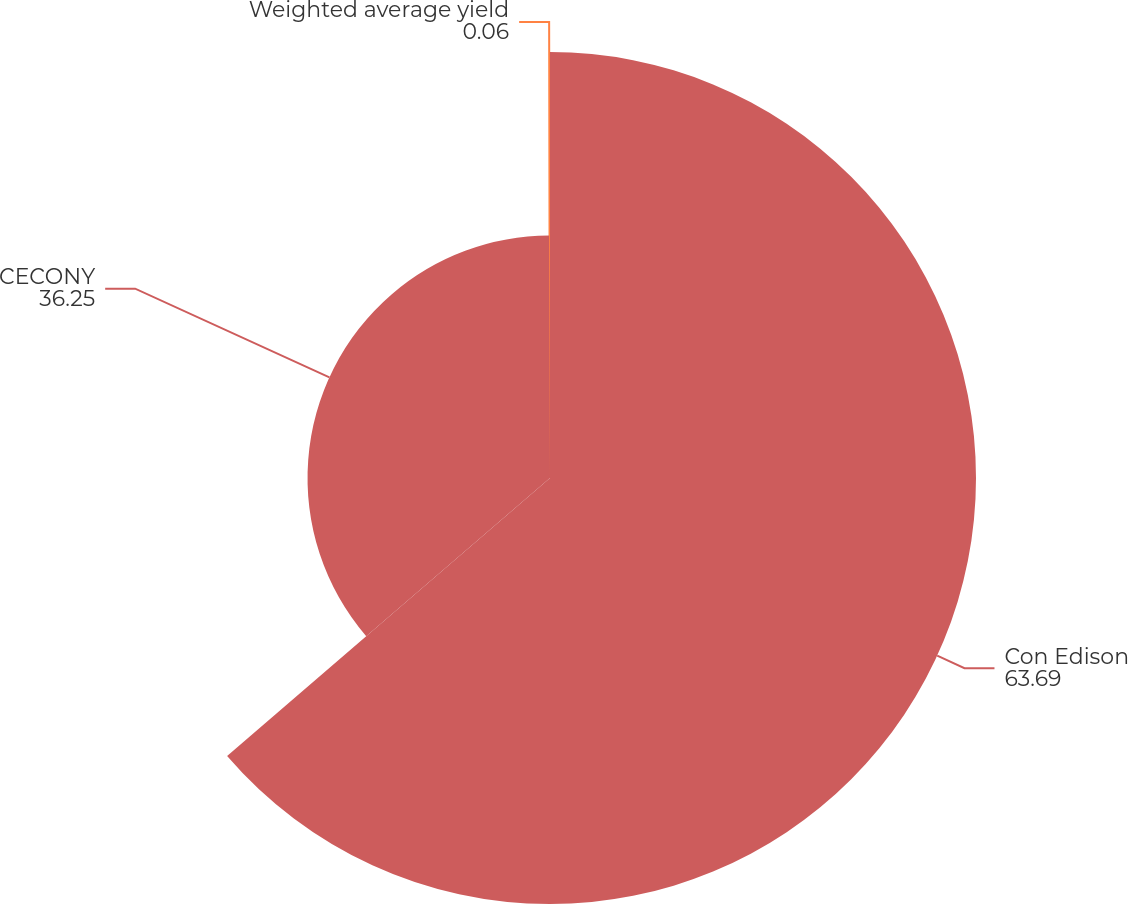<chart> <loc_0><loc_0><loc_500><loc_500><pie_chart><fcel>Con Edison<fcel>CECONY<fcel>Weighted average yield<nl><fcel>63.69%<fcel>36.25%<fcel>0.06%<nl></chart> 